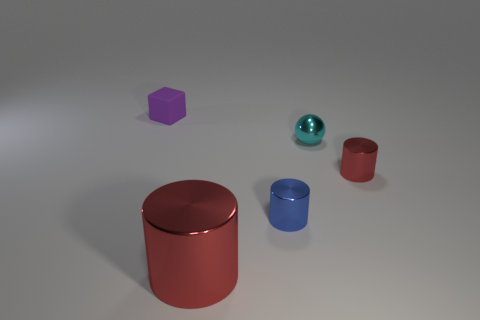Subtract all red shiny cylinders. How many cylinders are left? 1 Add 3 small cyan things. How many objects exist? 8 Subtract 1 spheres. How many spheres are left? 0 Subtract all cylinders. How many objects are left? 2 Subtract all red cylinders. How many cylinders are left? 1 Subtract all large brown matte things. Subtract all blue metallic objects. How many objects are left? 4 Add 5 shiny objects. How many shiny objects are left? 9 Add 1 rubber blocks. How many rubber blocks exist? 2 Subtract 0 brown blocks. How many objects are left? 5 Subtract all gray cylinders. Subtract all purple cubes. How many cylinders are left? 3 